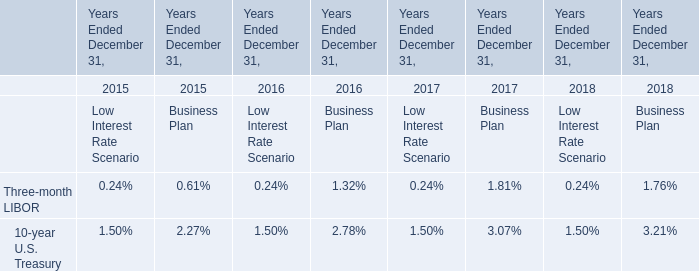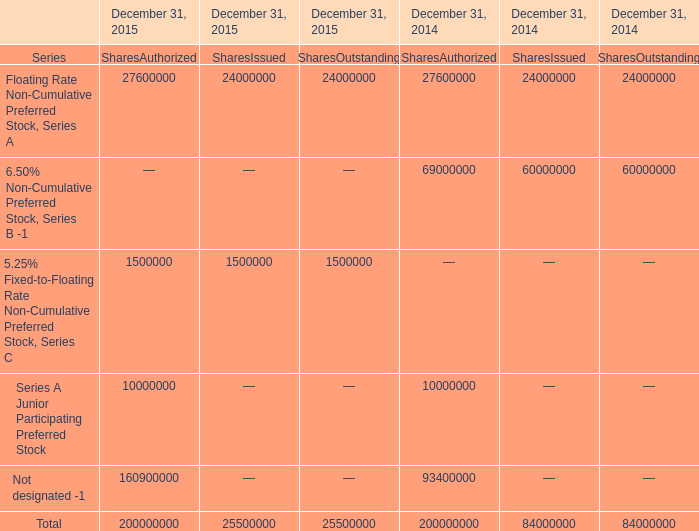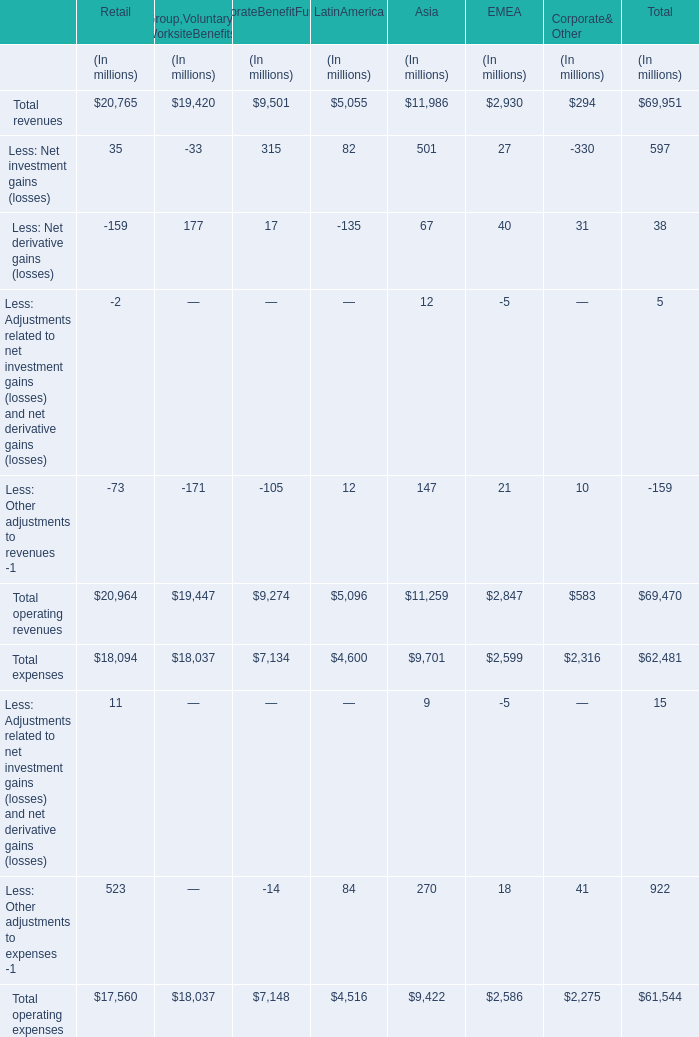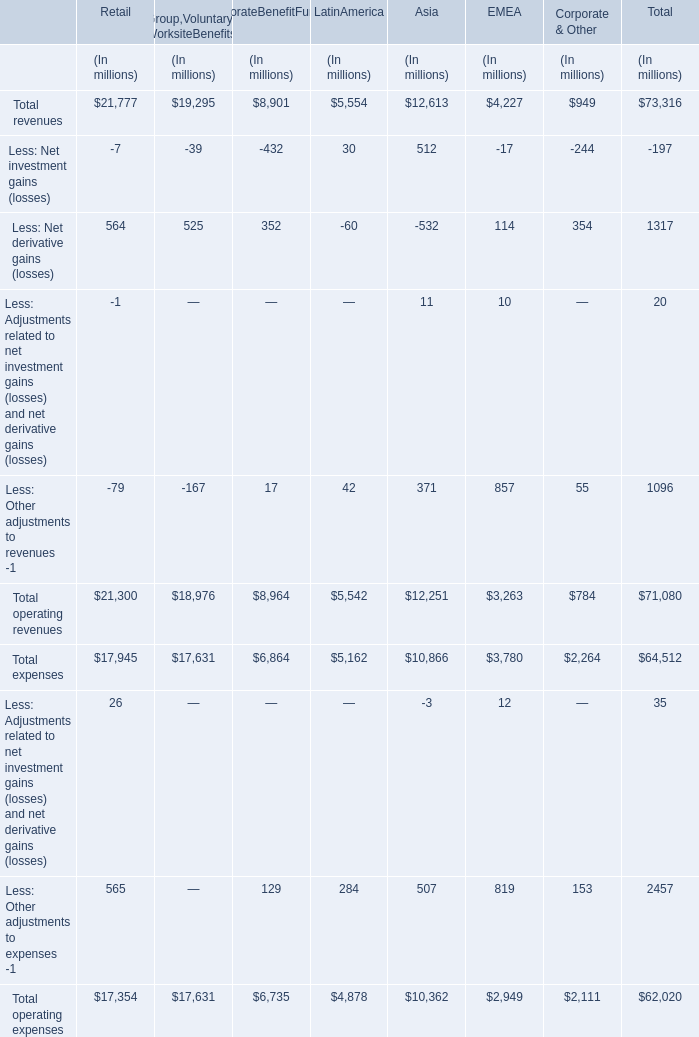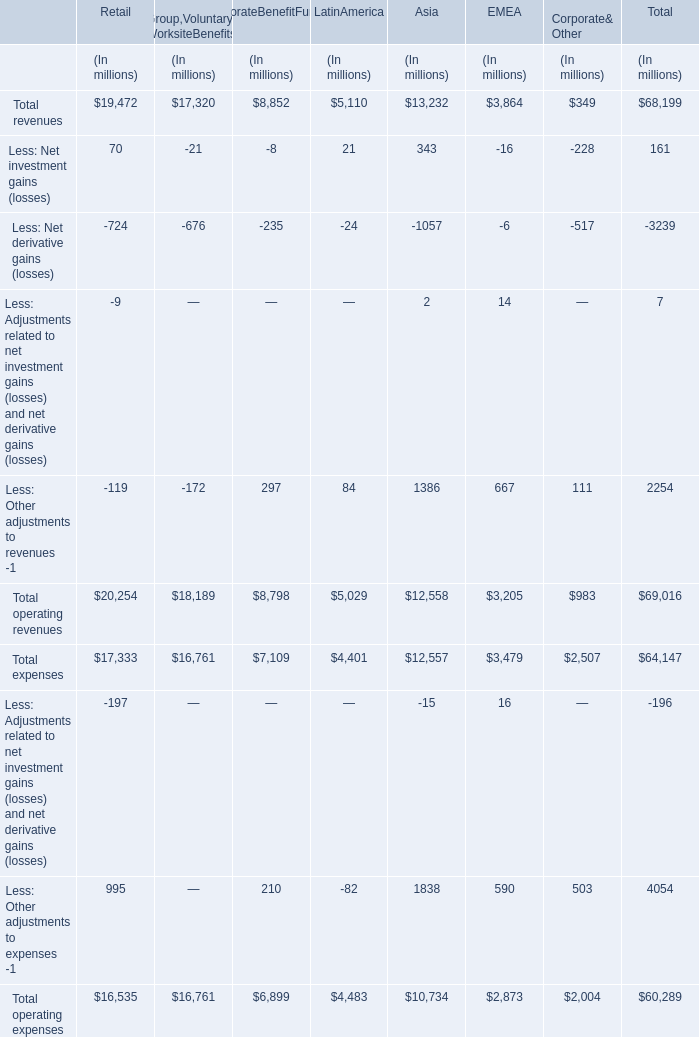How many expenses exceed the average of Total revenues ? (in million) 
Answer: 2. 